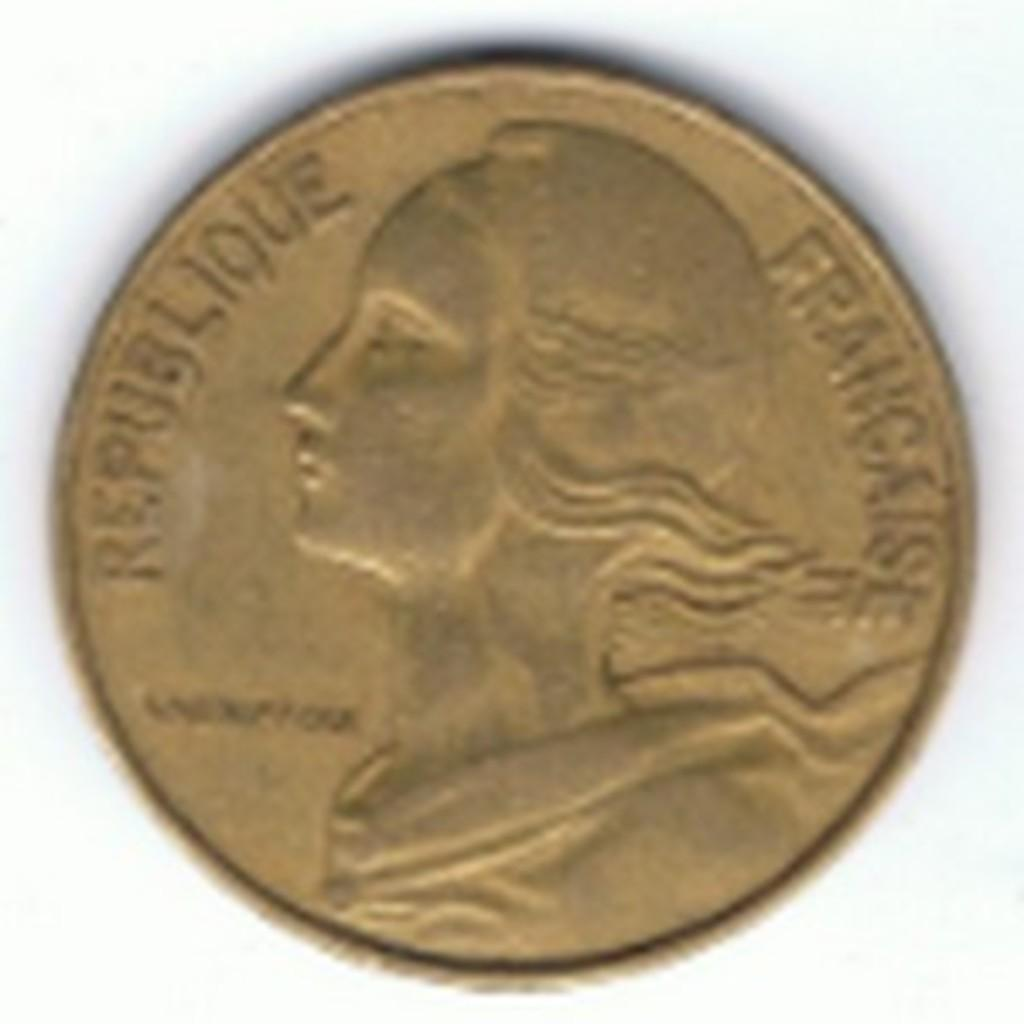<image>
Present a compact description of the photo's key features. A coin that says Republique Francais on it with a profile facing to the left. 